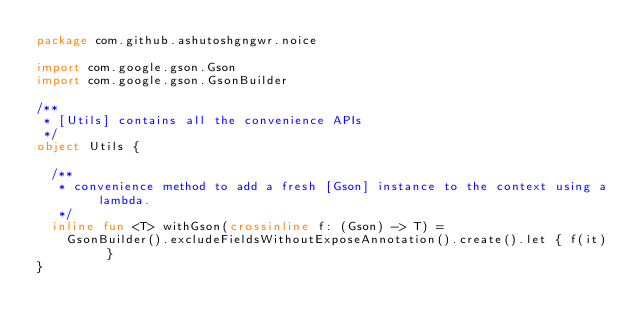Convert code to text. <code><loc_0><loc_0><loc_500><loc_500><_Kotlin_>package com.github.ashutoshgngwr.noice

import com.google.gson.Gson
import com.google.gson.GsonBuilder

/**
 * [Utils] contains all the convenience APIs
 */
object Utils {

  /**
   * convenience method to add a fresh [Gson] instance to the context using a lambda.
   */
  inline fun <T> withGson(crossinline f: (Gson) -> T) =
    GsonBuilder().excludeFieldsWithoutExposeAnnotation().create().let { f(it) }
}
</code> 